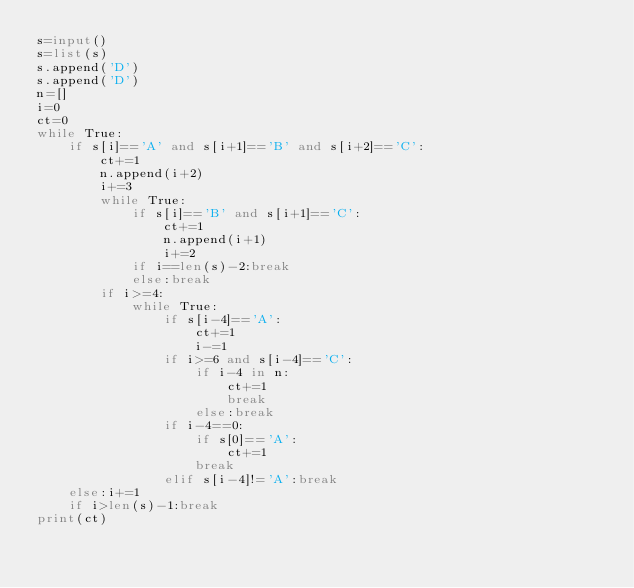<code> <loc_0><loc_0><loc_500><loc_500><_Python_>s=input()
s=list(s)
s.append('D')
s.append('D')
n=[]
i=0
ct=0
while True:
    if s[i]=='A' and s[i+1]=='B' and s[i+2]=='C':
        ct+=1
        n.append(i+2)
        i+=3
        while True:
            if s[i]=='B' and s[i+1]=='C':
                ct+=1
                n.append(i+1)
                i+=2
            if i==len(s)-2:break
            else:break
        if i>=4:
            while True:
                if s[i-4]=='A':
                    ct+=1
                    i-=1
                if i>=6 and s[i-4]=='C':
                    if i-4 in n:
                        ct+=1
                        break
                    else:break
                if i-4==0:
                    if s[0]=='A':
                        ct+=1
                    break
                elif s[i-4]!='A':break
    else:i+=1
    if i>len(s)-1:break
print(ct)</code> 